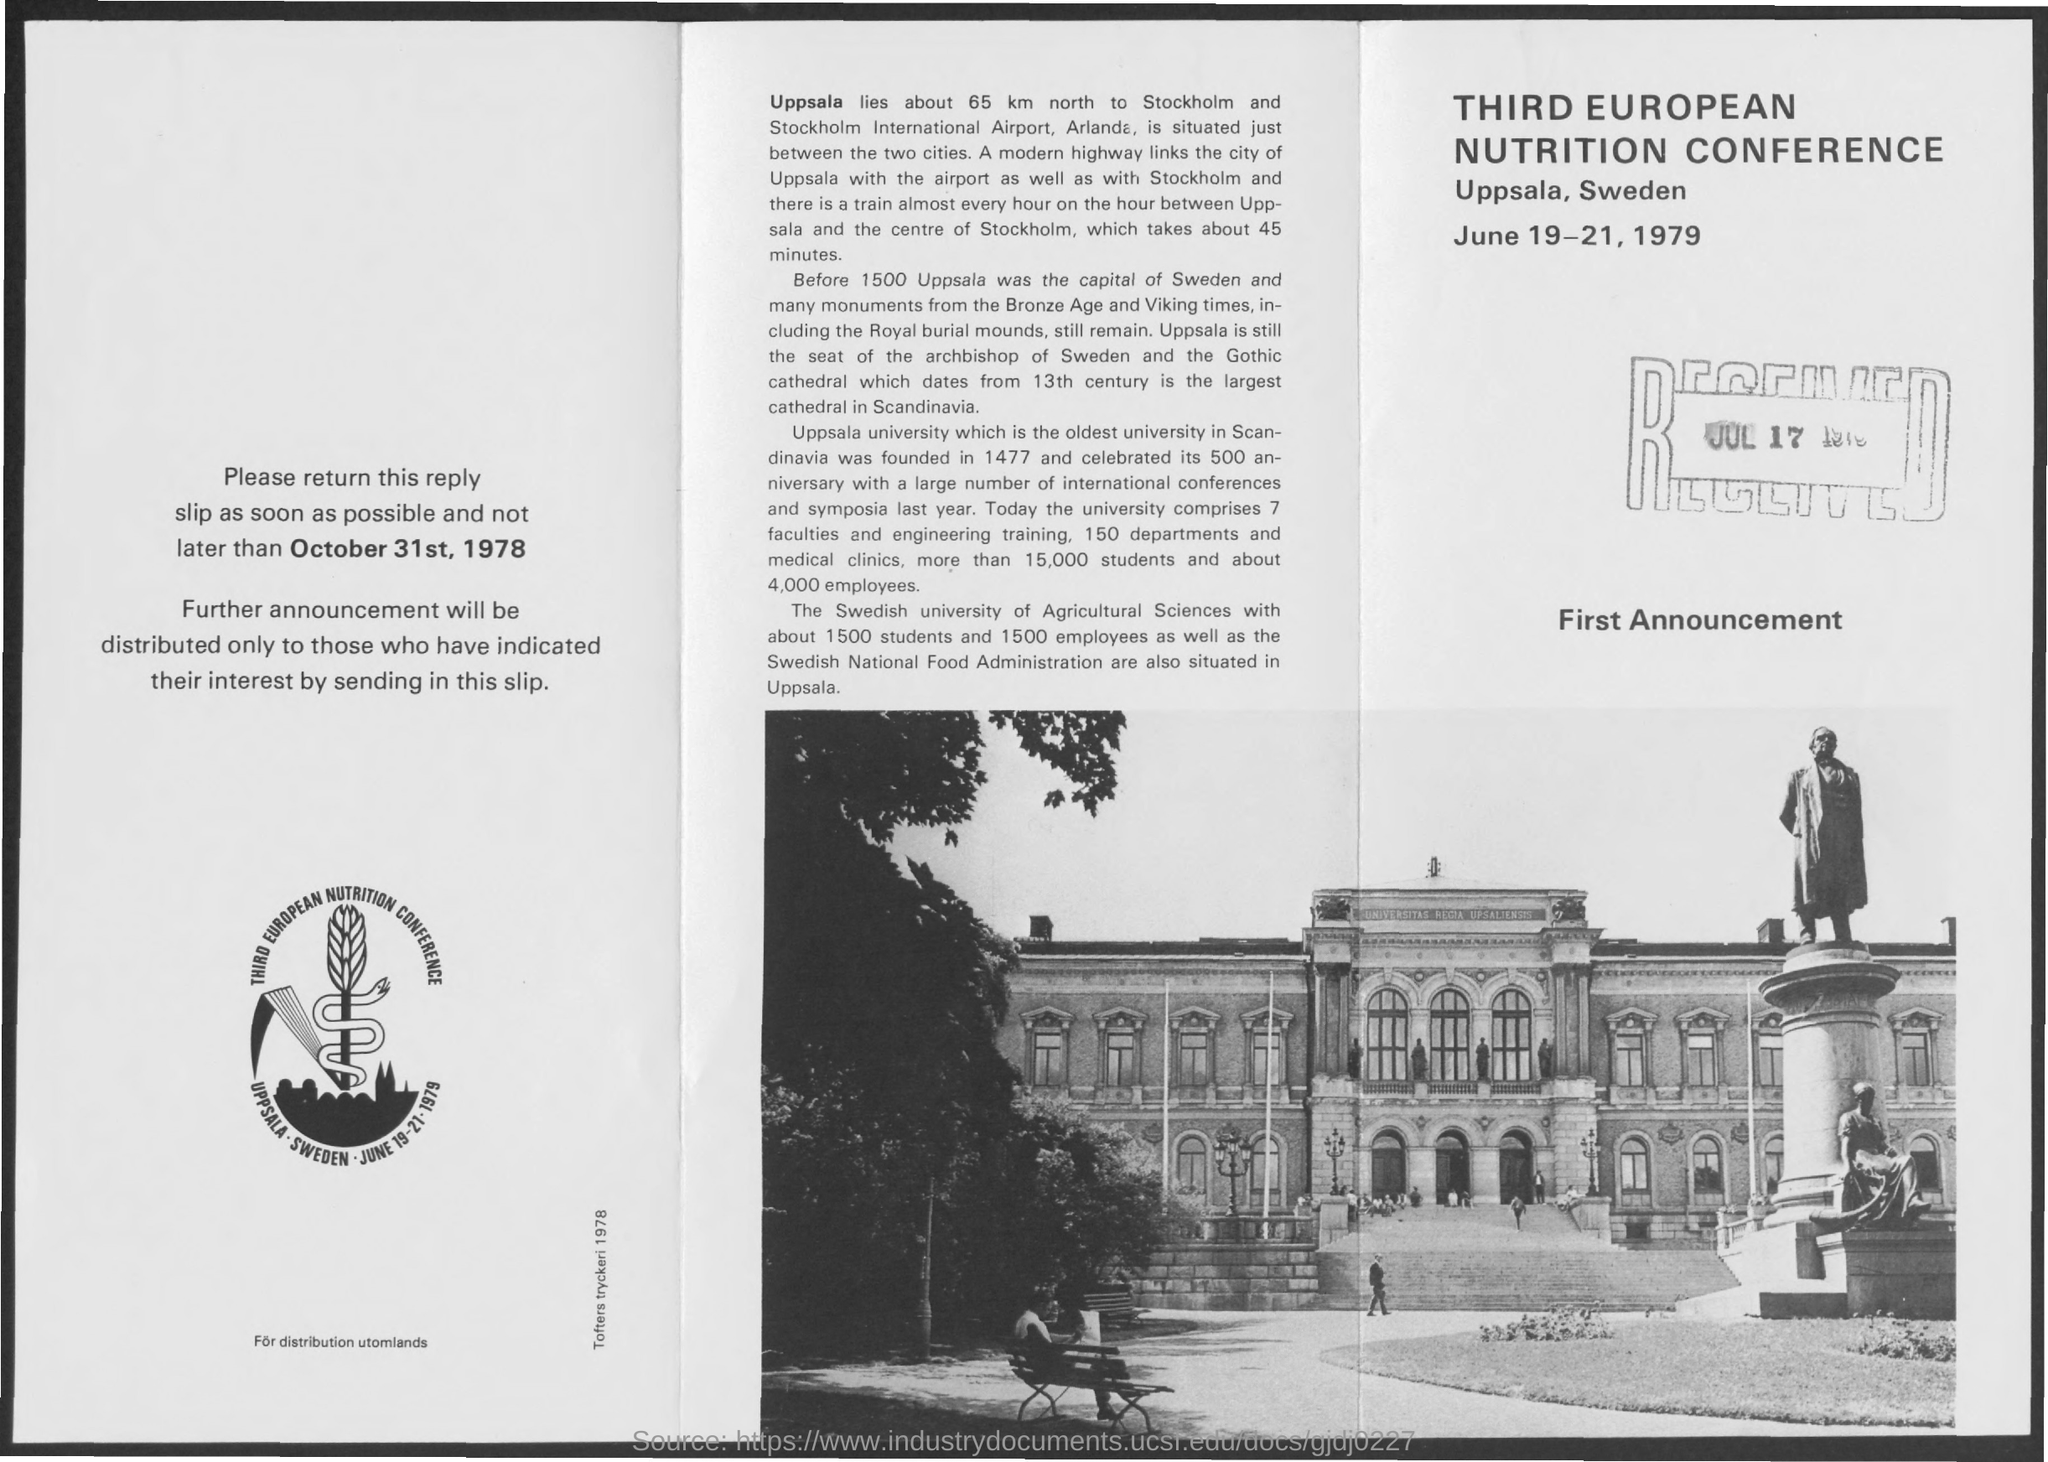Point out several critical features in this image. The Third European Nutrition Conference was held from June 19-21, 1979. The Third European Nutrition Conference was held at Uppsala, Sweden. 